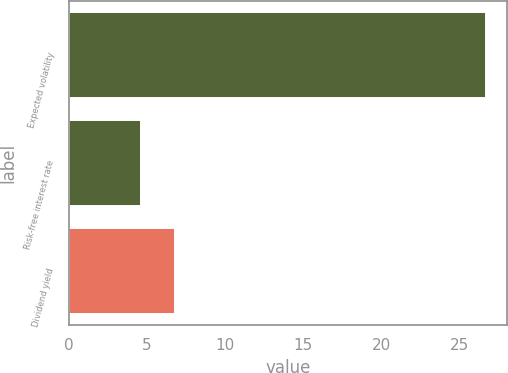Convert chart. <chart><loc_0><loc_0><loc_500><loc_500><bar_chart><fcel>Expected volatility<fcel>Risk-free interest rate<fcel>Dividend yield<nl><fcel>26.7<fcel>4.6<fcel>6.81<nl></chart> 